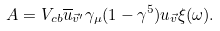Convert formula to latex. <formula><loc_0><loc_0><loc_500><loc_500>A = V _ { c b } \overline { u } _ { \vec { v } ^ { \prime } } \gamma _ { \mu } ( 1 - \gamma ^ { 5 } ) u _ { \vec { v } } \xi ( \omega ) .</formula> 